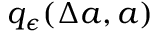<formula> <loc_0><loc_0><loc_500><loc_500>q _ { \epsilon } ( \Delta a , a )</formula> 